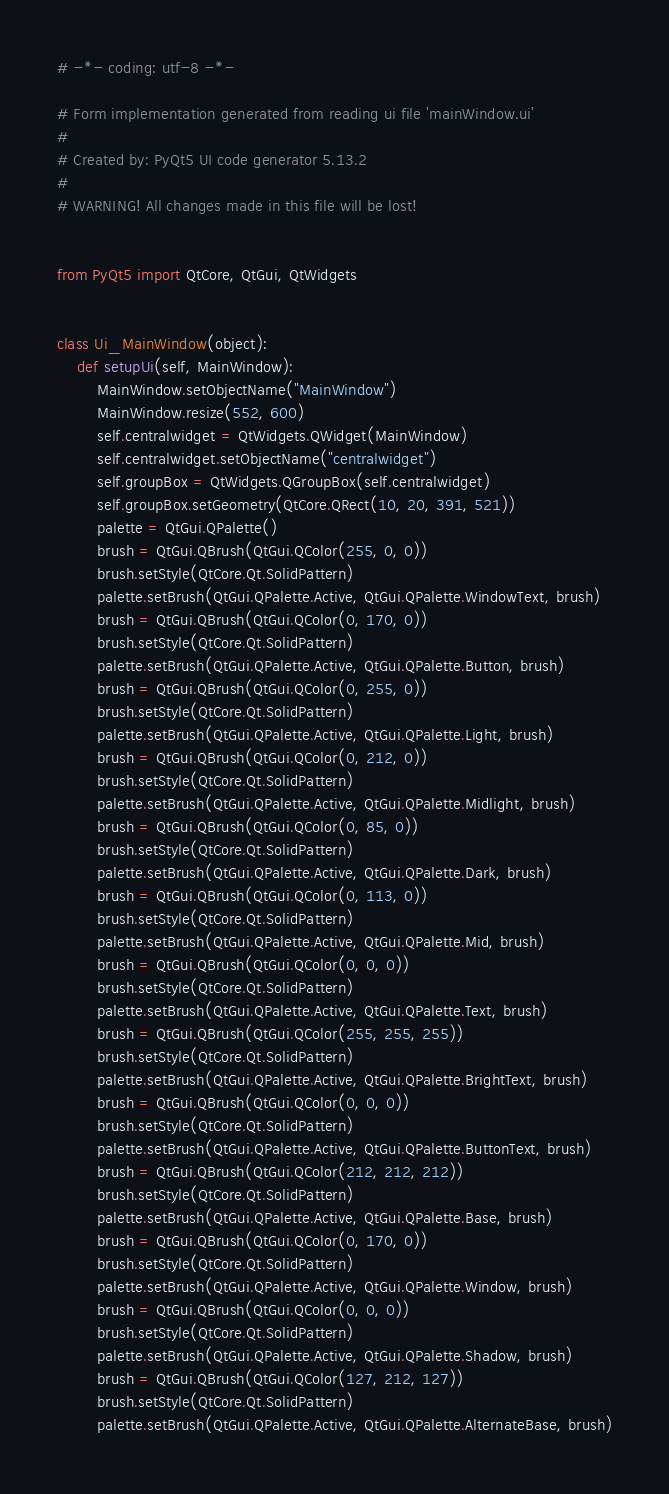Convert code to text. <code><loc_0><loc_0><loc_500><loc_500><_Python_># -*- coding: utf-8 -*-

# Form implementation generated from reading ui file 'mainWindow.ui'
#
# Created by: PyQt5 UI code generator 5.13.2
#
# WARNING! All changes made in this file will be lost!


from PyQt5 import QtCore, QtGui, QtWidgets


class Ui_MainWindow(object):
    def setupUi(self, MainWindow):
        MainWindow.setObjectName("MainWindow")
        MainWindow.resize(552, 600)
        self.centralwidget = QtWidgets.QWidget(MainWindow)
        self.centralwidget.setObjectName("centralwidget")
        self.groupBox = QtWidgets.QGroupBox(self.centralwidget)
        self.groupBox.setGeometry(QtCore.QRect(10, 20, 391, 521))
        palette = QtGui.QPalette()
        brush = QtGui.QBrush(QtGui.QColor(255, 0, 0))
        brush.setStyle(QtCore.Qt.SolidPattern)
        palette.setBrush(QtGui.QPalette.Active, QtGui.QPalette.WindowText, brush)
        brush = QtGui.QBrush(QtGui.QColor(0, 170, 0))
        brush.setStyle(QtCore.Qt.SolidPattern)
        palette.setBrush(QtGui.QPalette.Active, QtGui.QPalette.Button, brush)
        brush = QtGui.QBrush(QtGui.QColor(0, 255, 0))
        brush.setStyle(QtCore.Qt.SolidPattern)
        palette.setBrush(QtGui.QPalette.Active, QtGui.QPalette.Light, brush)
        brush = QtGui.QBrush(QtGui.QColor(0, 212, 0))
        brush.setStyle(QtCore.Qt.SolidPattern)
        palette.setBrush(QtGui.QPalette.Active, QtGui.QPalette.Midlight, brush)
        brush = QtGui.QBrush(QtGui.QColor(0, 85, 0))
        brush.setStyle(QtCore.Qt.SolidPattern)
        palette.setBrush(QtGui.QPalette.Active, QtGui.QPalette.Dark, brush)
        brush = QtGui.QBrush(QtGui.QColor(0, 113, 0))
        brush.setStyle(QtCore.Qt.SolidPattern)
        palette.setBrush(QtGui.QPalette.Active, QtGui.QPalette.Mid, brush)
        brush = QtGui.QBrush(QtGui.QColor(0, 0, 0))
        brush.setStyle(QtCore.Qt.SolidPattern)
        palette.setBrush(QtGui.QPalette.Active, QtGui.QPalette.Text, brush)
        brush = QtGui.QBrush(QtGui.QColor(255, 255, 255))
        brush.setStyle(QtCore.Qt.SolidPattern)
        palette.setBrush(QtGui.QPalette.Active, QtGui.QPalette.BrightText, brush)
        brush = QtGui.QBrush(QtGui.QColor(0, 0, 0))
        brush.setStyle(QtCore.Qt.SolidPattern)
        palette.setBrush(QtGui.QPalette.Active, QtGui.QPalette.ButtonText, brush)
        brush = QtGui.QBrush(QtGui.QColor(212, 212, 212))
        brush.setStyle(QtCore.Qt.SolidPattern)
        palette.setBrush(QtGui.QPalette.Active, QtGui.QPalette.Base, brush)
        brush = QtGui.QBrush(QtGui.QColor(0, 170, 0))
        brush.setStyle(QtCore.Qt.SolidPattern)
        palette.setBrush(QtGui.QPalette.Active, QtGui.QPalette.Window, brush)
        brush = QtGui.QBrush(QtGui.QColor(0, 0, 0))
        brush.setStyle(QtCore.Qt.SolidPattern)
        palette.setBrush(QtGui.QPalette.Active, QtGui.QPalette.Shadow, brush)
        brush = QtGui.QBrush(QtGui.QColor(127, 212, 127))
        brush.setStyle(QtCore.Qt.SolidPattern)
        palette.setBrush(QtGui.QPalette.Active, QtGui.QPalette.AlternateBase, brush)</code> 